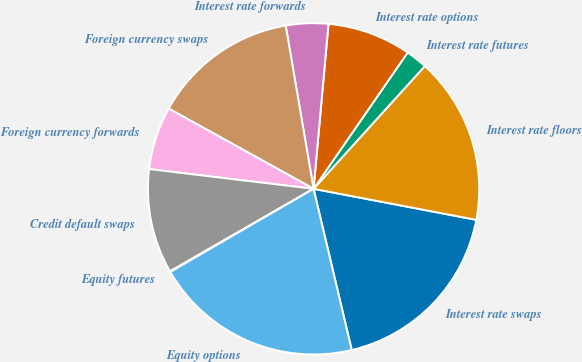Convert chart to OTSL. <chart><loc_0><loc_0><loc_500><loc_500><pie_chart><fcel>Interest rate swaps<fcel>Interest rate floors<fcel>Interest rate futures<fcel>Interest rate options<fcel>Interest rate forwards<fcel>Foreign currency swaps<fcel>Foreign currency forwards<fcel>Credit default swaps<fcel>Equity futures<fcel>Equity options<nl><fcel>18.3%<fcel>16.28%<fcel>2.1%<fcel>8.18%<fcel>4.13%<fcel>14.25%<fcel>6.15%<fcel>10.2%<fcel>0.07%<fcel>20.33%<nl></chart> 